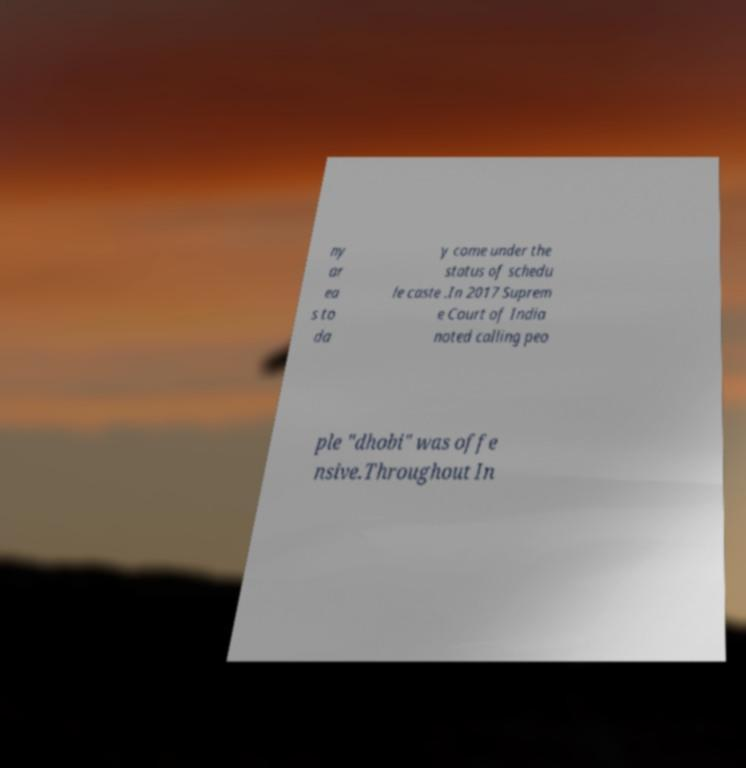Please identify and transcribe the text found in this image. ny ar ea s to da y come under the status of schedu le caste .In 2017 Suprem e Court of India noted calling peo ple "dhobi" was offe nsive.Throughout In 